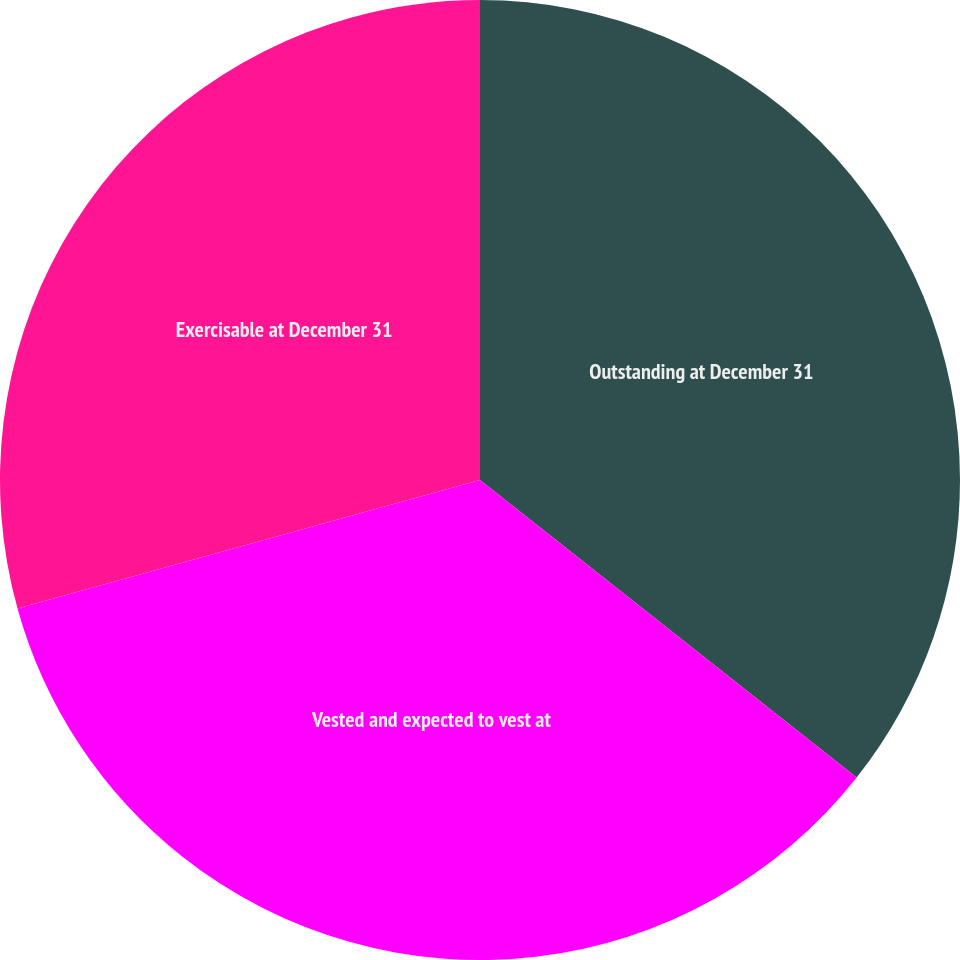Convert chart. <chart><loc_0><loc_0><loc_500><loc_500><pie_chart><fcel>Outstanding at December 31<fcel>Vested and expected to vest at<fcel>Exercisable at December 31<nl><fcel>35.64%<fcel>35.05%<fcel>29.31%<nl></chart> 